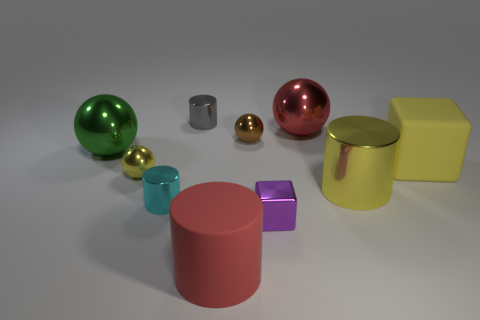Is the color of the matte cylinder the same as the big cube?
Keep it short and to the point. No. There is a large red thing that is right of the red object left of the purple block; what number of brown spheres are on the left side of it?
Provide a succinct answer. 1. How many blocks are there?
Offer a terse response. 2. Are there fewer objects behind the large green shiny sphere than tiny cyan metal cylinders that are left of the brown shiny ball?
Keep it short and to the point. No. Are there fewer gray metal objects to the left of the large green object than large blue blocks?
Your response must be concise. No. What material is the big object that is behind the small ball that is behind the yellow shiny thing that is on the left side of the small gray thing?
Provide a succinct answer. Metal. How many things are metallic spheres on the left side of the gray metallic thing or small cylinders behind the large green sphere?
Give a very brief answer. 3. There is a red object that is the same shape as the small cyan shiny object; what is it made of?
Offer a terse response. Rubber. What number of metal objects are big blue cubes or cyan things?
Your answer should be compact. 1. What is the shape of the small gray object that is made of the same material as the green sphere?
Offer a terse response. Cylinder. 